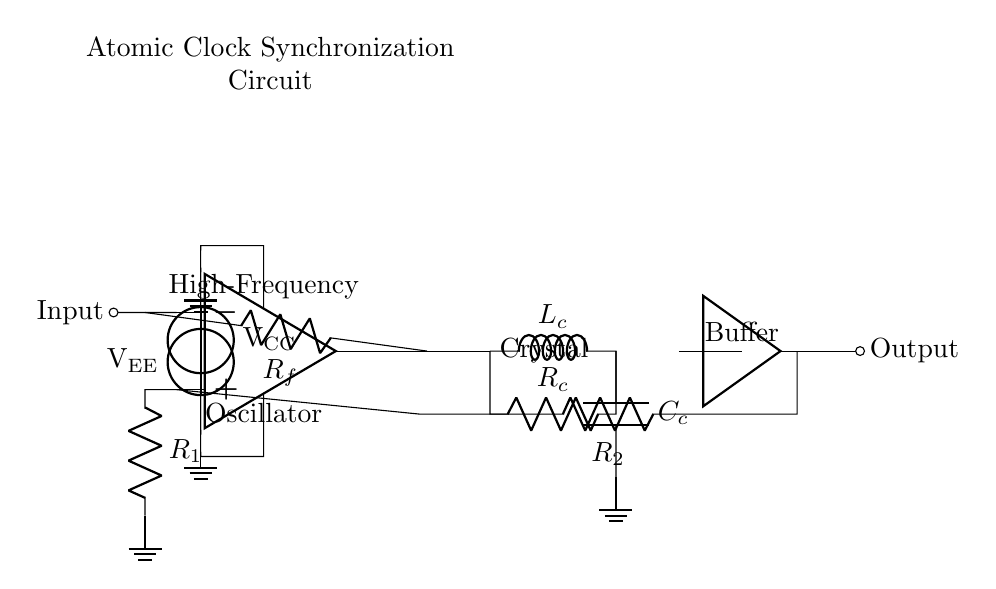What is the type of circuit shown? The circuit is an oscillator circuit, which is used to generate a periodic signal. This is evident from the op amp component and the feedback configuration.
Answer: Oscillator What is the feedback resistor in this circuit? The feedback resistor R2 connects back to the positive input of the op-amp and is crucial for the oscillation process. It's indicated in the diagram.
Answer: R2 How many frequency-determining components are in this circuit? There are two frequency-determining components: an inductor Lc and a capacitor Cc, which work together to define the oscillation frequency.
Answer: Two What is the power supply voltage labeled as? The power supply voltages are labeled as VCC for positive voltage and VEE for negative voltage. These define the operating ranges of the op-amp.
Answer: VCC and VEE What is the purpose of the buffer in this circuit? The buffer is used to isolate the oscillator output from the load, preventing the load from affecting oscillation stability and ensuring a strong output signal.
Answer: Isolation What happens if the value of R1 is increased? Increasing R1 can lead to a lower gain in the op-amp configuration, which may affect the stability and frequency of the oscillations by reducing the overall loop gain.
Answer: Lower gain Which component provides the synchronization for atomic clocks? The crystal component in the circuit is responsible for providing the stable frequency reference needed for synchronization in atomic clocks.
Answer: Crystal 